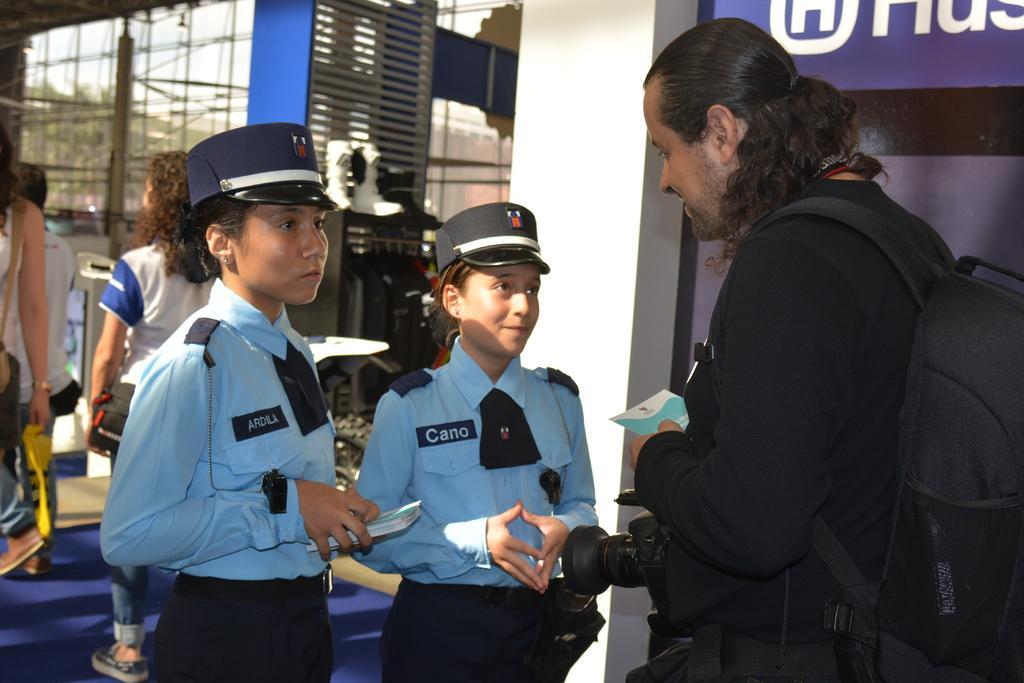In one or two sentences, can you explain what this image depicts? In the image in the center we can see three persons were standing. And the right side person is wearing backpack. And we can see they were holding pamphlets. In the background there is a building,wall,banner,carpet,glass,racks,shoes,few people were walking and holding some objects etc. 